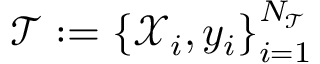<formula> <loc_0><loc_0><loc_500><loc_500>\mathcal { T } \colon = \left \{ \mathcal { X } _ { i } , y _ { i } \right \} _ { i = 1 } ^ { N _ { \mathcal { T } } }</formula> 